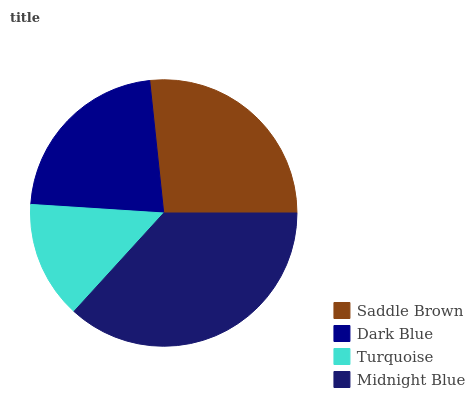Is Turquoise the minimum?
Answer yes or no. Yes. Is Midnight Blue the maximum?
Answer yes or no. Yes. Is Dark Blue the minimum?
Answer yes or no. No. Is Dark Blue the maximum?
Answer yes or no. No. Is Saddle Brown greater than Dark Blue?
Answer yes or no. Yes. Is Dark Blue less than Saddle Brown?
Answer yes or no. Yes. Is Dark Blue greater than Saddle Brown?
Answer yes or no. No. Is Saddle Brown less than Dark Blue?
Answer yes or no. No. Is Saddle Brown the high median?
Answer yes or no. Yes. Is Dark Blue the low median?
Answer yes or no. Yes. Is Dark Blue the high median?
Answer yes or no. No. Is Turquoise the low median?
Answer yes or no. No. 